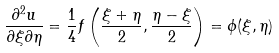Convert formula to latex. <formula><loc_0><loc_0><loc_500><loc_500>\frac { \partial ^ { 2 } u } { \partial \xi \partial \eta } = \frac { 1 } { 4 } f \left ( \frac { \xi + \eta } { 2 } , \frac { \eta - \xi } { 2 } \right ) = \phi ( \xi , \eta )</formula> 